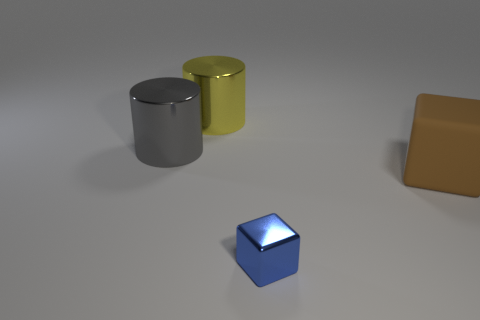Add 3 big red metallic things. How many objects exist? 7 Subtract all gray spheres. Subtract all metallic cylinders. How many objects are left? 2 Add 4 tiny blue things. How many tiny blue things are left? 5 Add 4 brown rubber cubes. How many brown rubber cubes exist? 5 Subtract 0 cyan spheres. How many objects are left? 4 